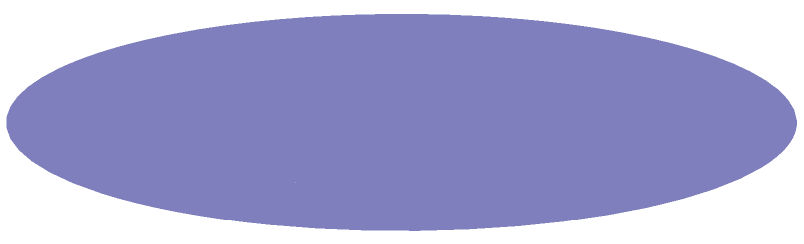A new military base requires a cylindrical water tank with a radius of 10 meters and a height of 15 meters. As an urban planner, you need to calculate the volume of this tank to ensure it meets the base's water storage needs. What is the volume of the tank in cubic meters? To calculate the volume of a cylindrical tank, we use the formula:

$$V = \pi r^2 h$$

Where:
$V$ = volume
$r$ = radius
$h$ = height

Given:
$r = 10$ meters
$h = 15$ meters

Step 1: Substitute the values into the formula
$$V = \pi (10 \text{ m})^2 (15 \text{ m})$$

Step 2: Calculate $r^2$
$$V = \pi (100 \text{ m}^2) (15 \text{ m})$$

Step 3: Multiply all terms
$$V = 1500\pi \text{ m}^3$$

Step 4: Calculate the final value (rounded to nearest whole number)
$$V \approx 4712 \text{ m}^3$$
Answer: 4712 m³ 